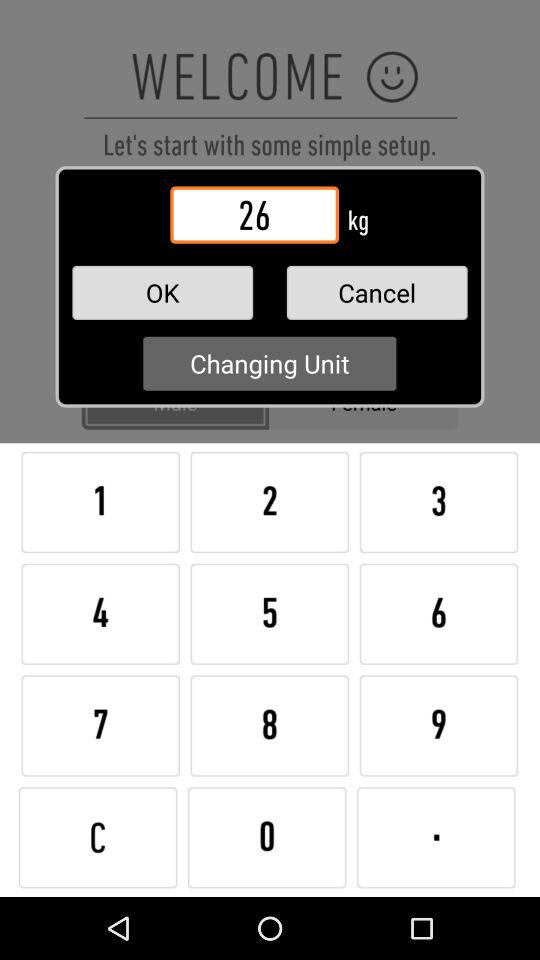What is the entered weight? The entered weight is 26 kg. 